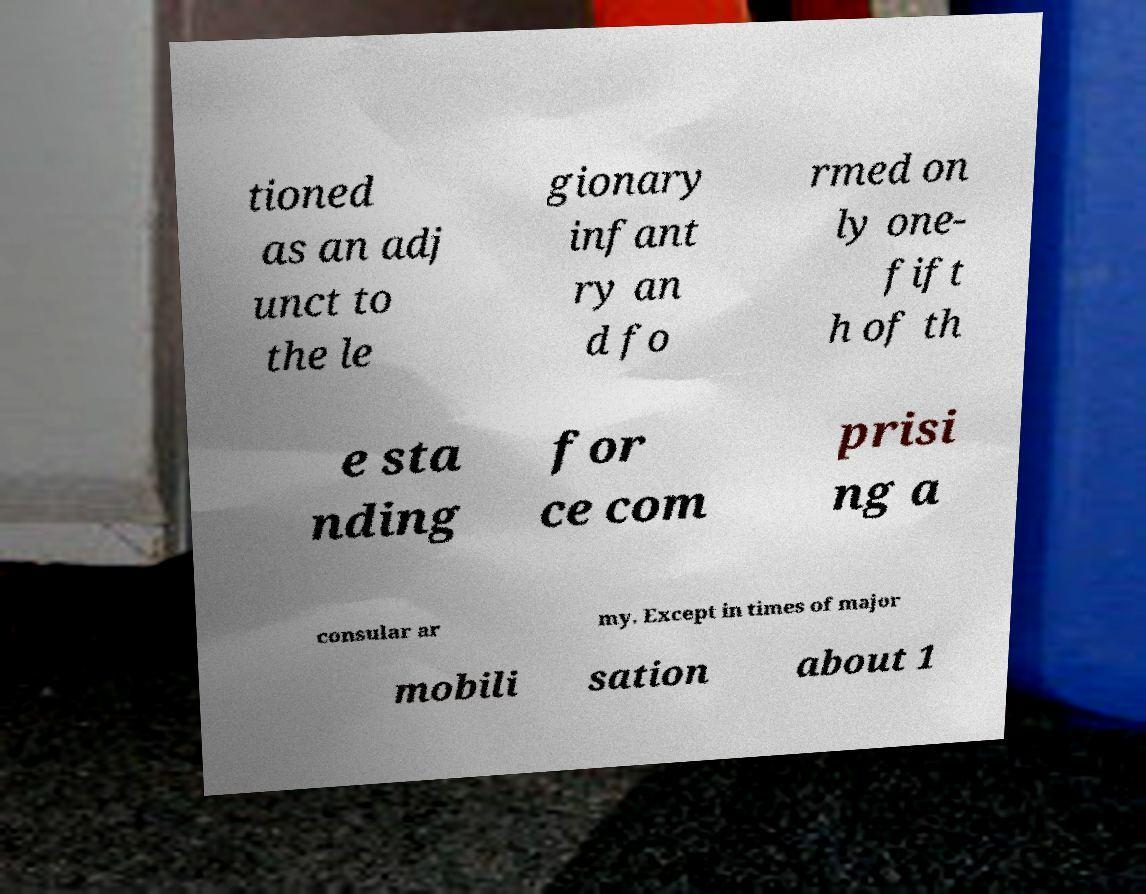Please identify and transcribe the text found in this image. tioned as an adj unct to the le gionary infant ry an d fo rmed on ly one- fift h of th e sta nding for ce com prisi ng a consular ar my. Except in times of major mobili sation about 1 